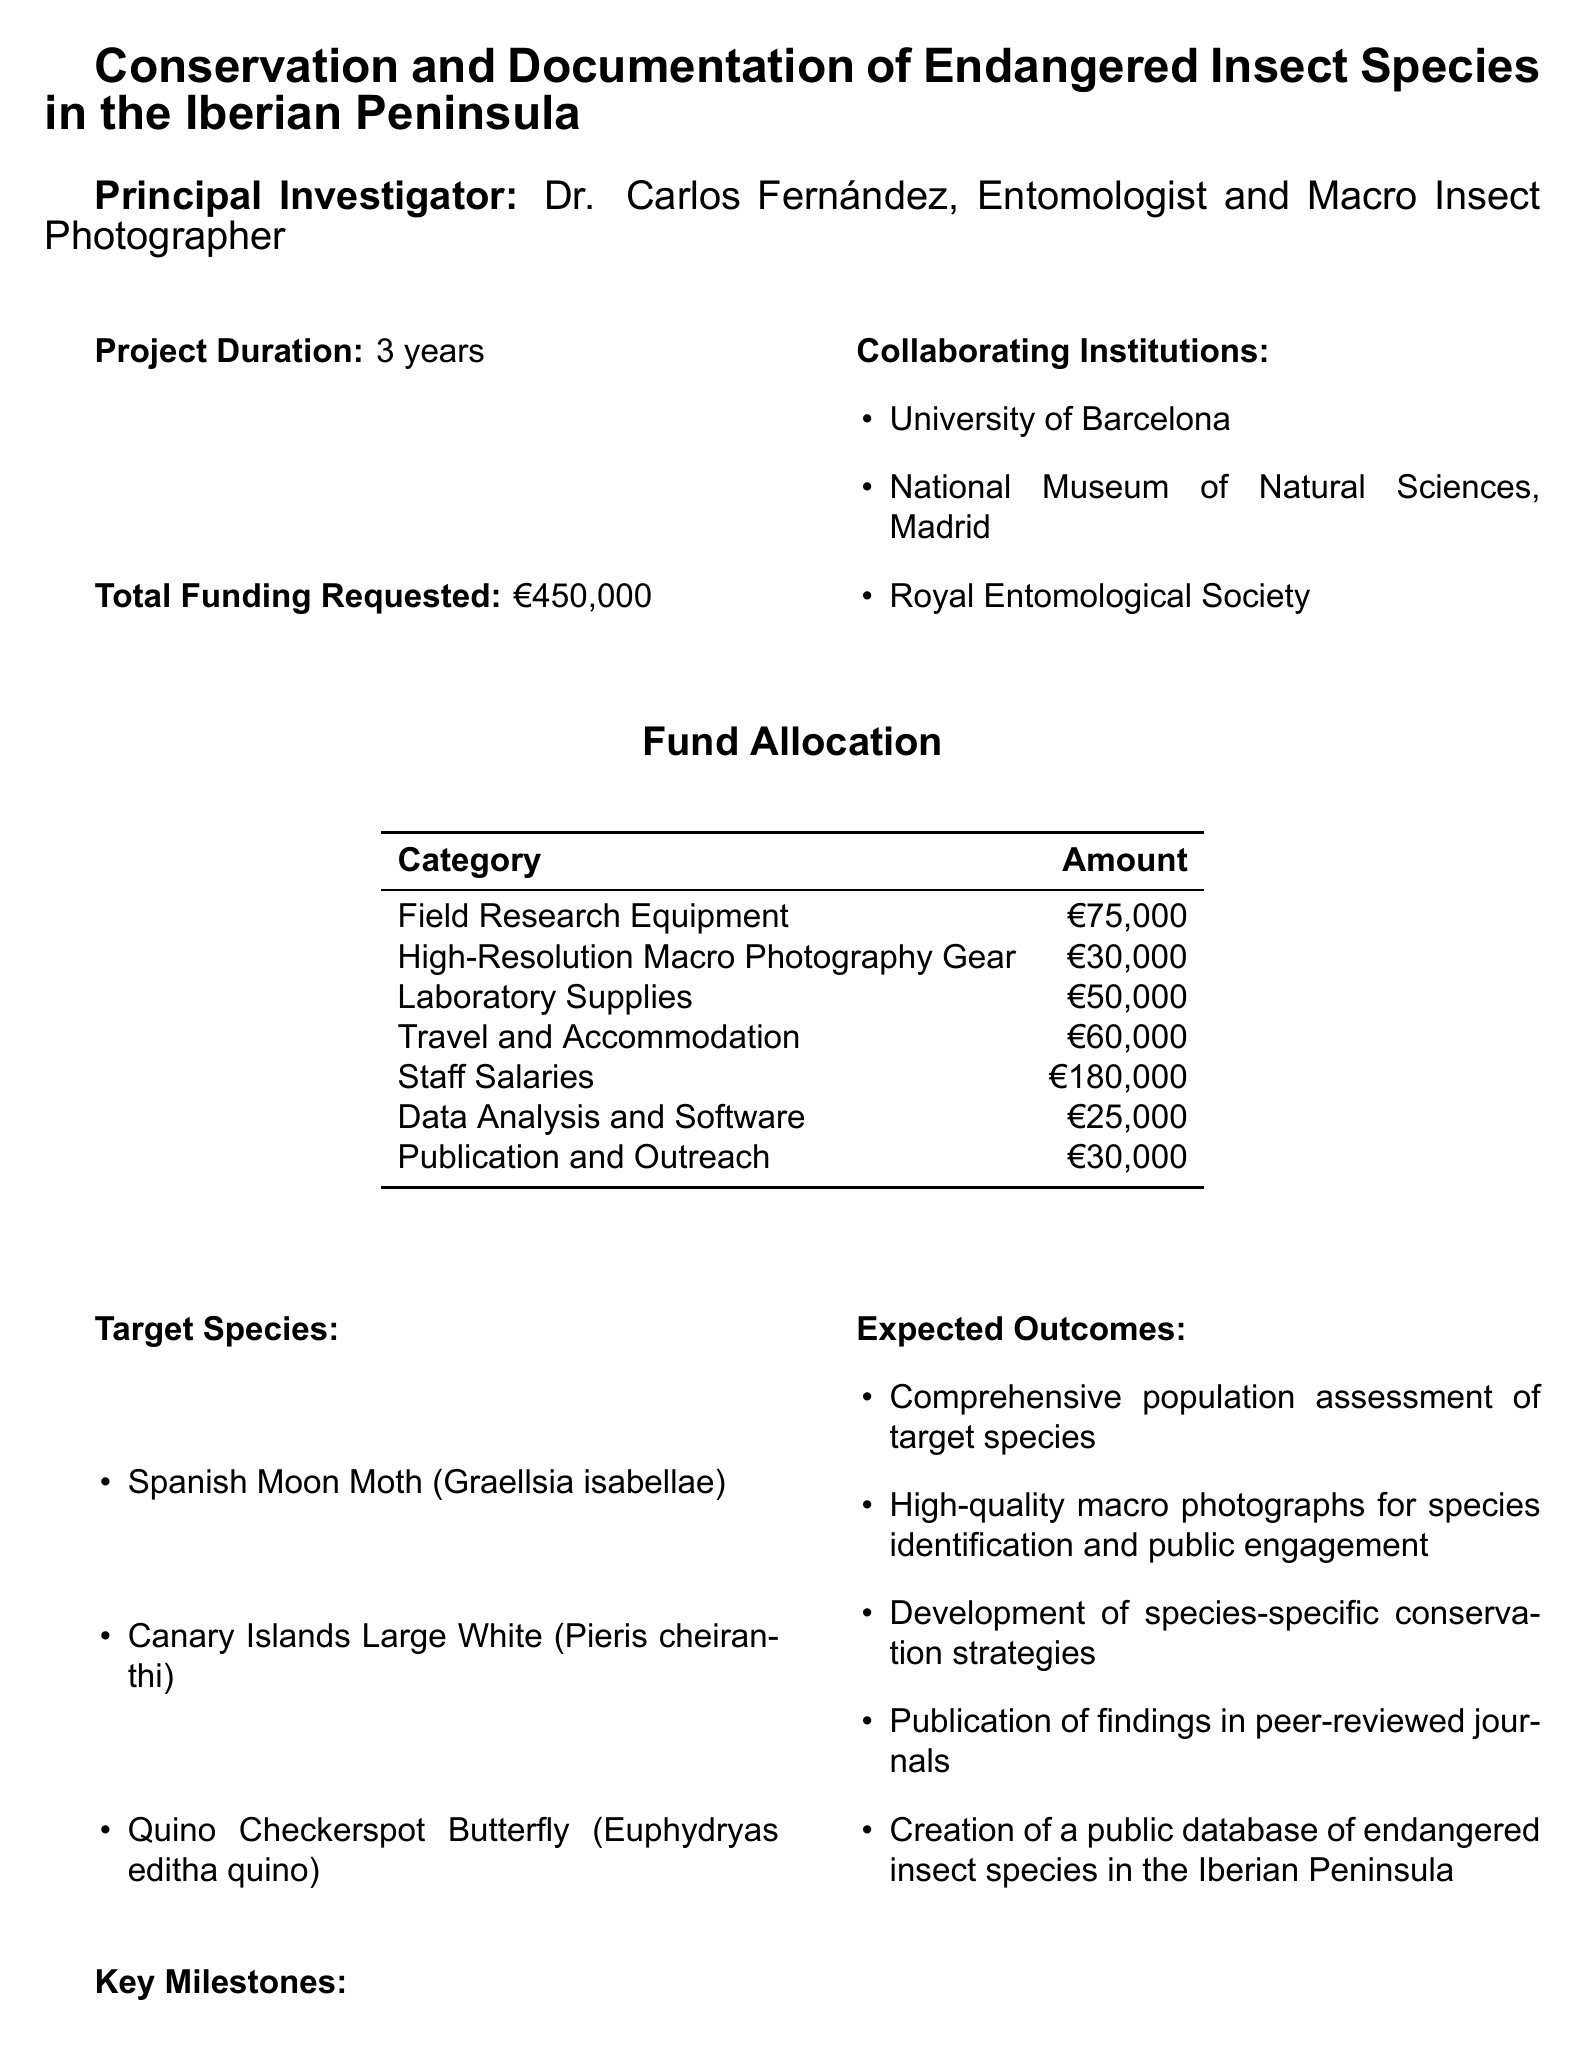What is the project title? The project title is stated at the beginning of the document, which is "Conservation and Documentation of Endangered Insect Species in the Iberian Peninsula."
Answer: Conservation and Documentation of Endangered Insect Species in the Iberian Peninsula Who is the principal investigator? The principal investigator's name is mentioned in the document, which is "Dr. Carlos Fernández, Entomologist and Macro Insect Photographer."
Answer: Dr. Carlos Fernández What is the total funding requested? The total funding amount requested is specified as €450,000 in the document.
Answer: €450,000 How long is the project duration? The document indicates the project duration, which is stated as 3 years.
Answer: 3 years What are the target species? The document lists specific insect species targeted by the project: "Spanish Moon Moth," "Canary Islands Large White," and "Quino Checkerspot Butterfly."
Answer: Spanish Moon Moth, Canary Islands Large White, Quino Checkerspot Butterfly What is the largest allocation of funds? The allocation for "Staff Salaries" is highlighted in the document as the largest funding category at €180,000.
Answer: €180,000 What is one expected outcome of the project? The document describes several expected outcomes, including "Comprehensive population assessment of target species."
Answer: Comprehensive population assessment of target species What is a key milestone for Year 2? Year 2's key milestone is "Conduct in-depth habitat analysis and genetic sampling," as stated in the document.
Answer: Conduct in-depth habitat analysis and genetic sampling Which institutions are collaborating on the project? The document provides a list of collaborating institutions, which includes the "University of Barcelona," "National Museum of Natural Sciences, Madrid," and "Royal Entomological Society."
Answer: University of Barcelona, National Museum of Natural Sciences, Madrid, Royal Entomological Society 